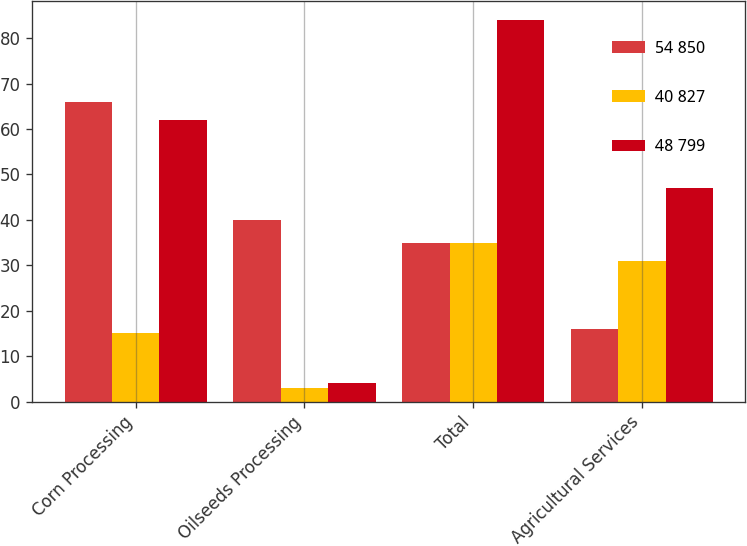Convert chart to OTSL. <chart><loc_0><loc_0><loc_500><loc_500><stacked_bar_chart><ecel><fcel>Corn Processing<fcel>Oilseeds Processing<fcel>Total<fcel>Agricultural Services<nl><fcel>54 850<fcel>66<fcel>40<fcel>35<fcel>16<nl><fcel>40 827<fcel>15<fcel>3<fcel>35<fcel>31<nl><fcel>48 799<fcel>62<fcel>4<fcel>84<fcel>47<nl></chart> 